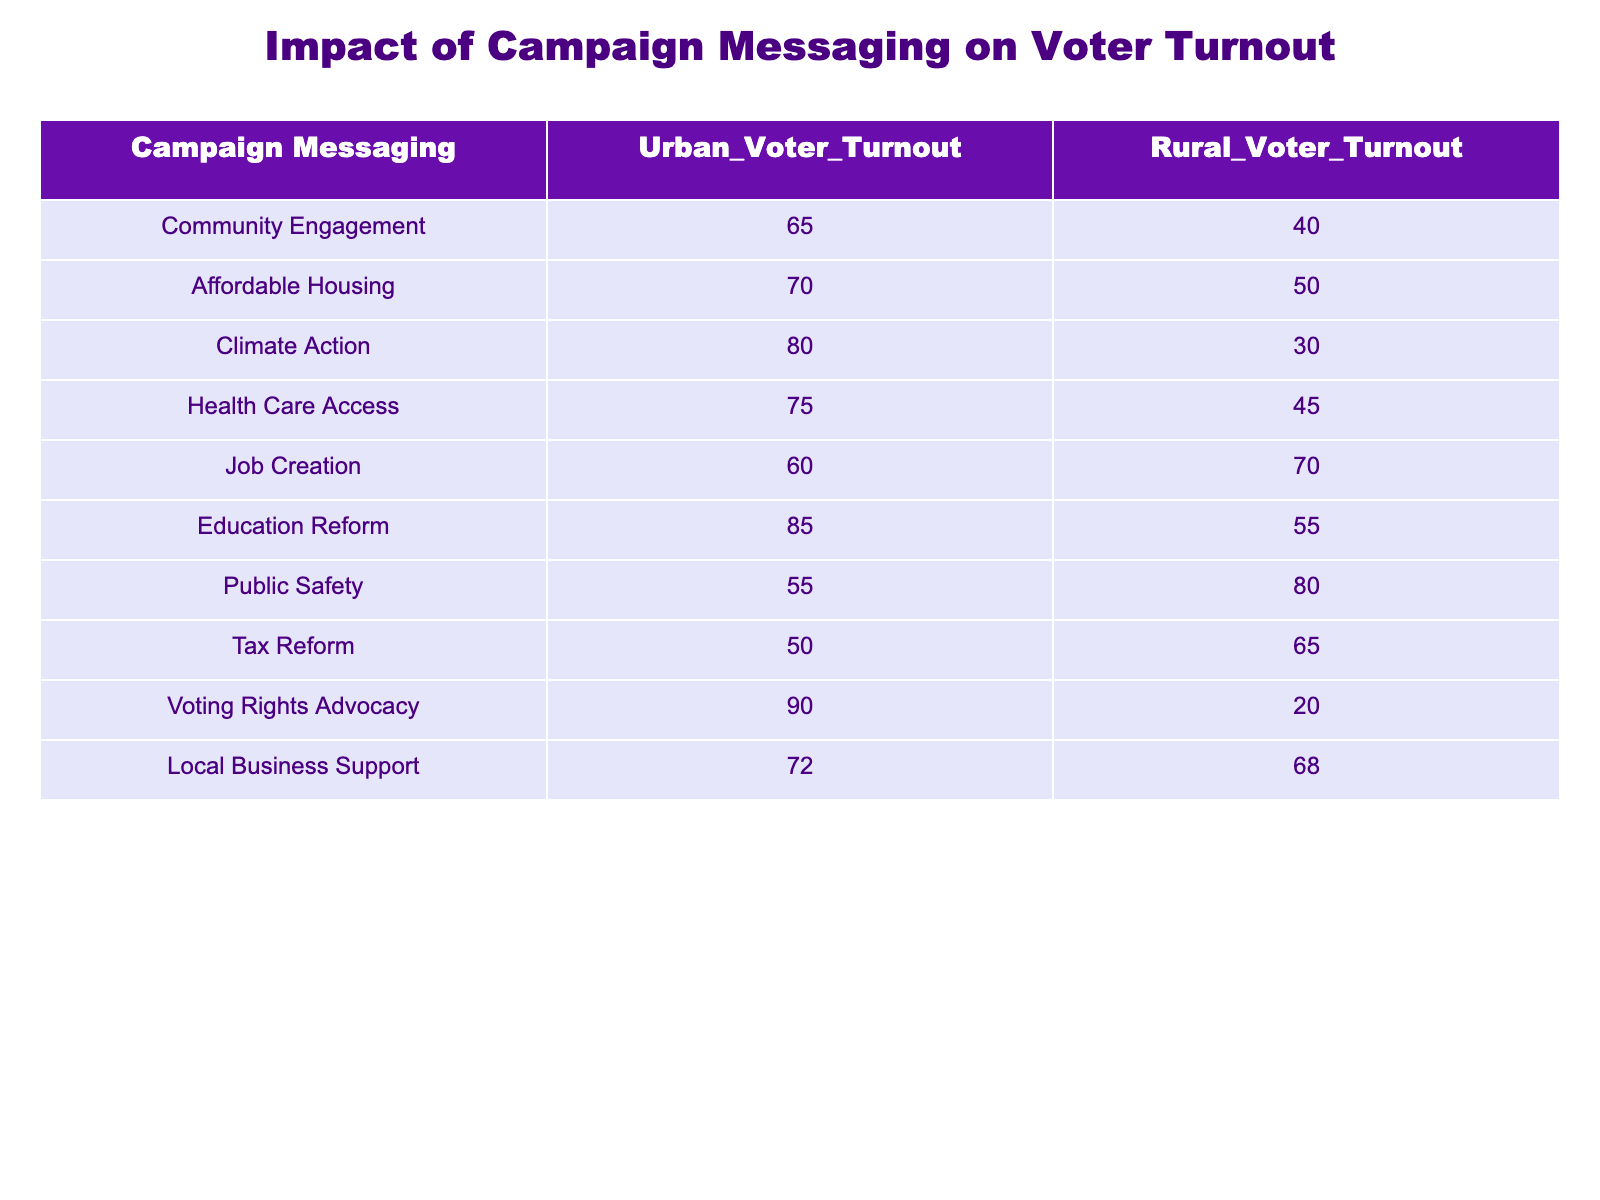What is the Urban Voter Turnout for "Climate Action"? The table lists the Urban Voter Turnout for each campaign messaging. For "Climate Action", the corresponding Urban Voter Turnout value is 80.
Answer: 80 What is the Rural Voter Turnout for "Job Creation"? Referring to the table, the Rural Voter Turnout for "Job Creation" is given as 70.
Answer: 70 Which campaign messaging has the lowest voter turnout in urban areas? By examining the Urban Voter Turnout values, "Tax Reform" shows the lowest turnout at 50 compared to other campaign messages.
Answer: Tax Reform Is the Urban Voter Turnout for "Local Business Support" higher than that for "Public Safety"? The Urban Voter Turnout for "Local Business Support" is 72 and for "Public Safety" it is 55. Since 72 is greater than 55, it is indeed higher.
Answer: Yes What is the average Urban Voter Turnout across all campaign messages? Adding the Urban Voter Turnout values (65 + 70 + 80 + 75 + 60 + 85 + 55 + 50 + 90 + 72 =  762) and dividing by the number of campaigns (10) yields an average of 76.2.
Answer: 76.2 Which messaging had the largest difference between Urban and Rural Voter Turnout? To find the largest difference, we calculate the absolute differences for each messaging: Climate Action: 50, Job Creation: 10, and so on. "Voting Rights Advocacy" has the largest difference of 70 (90-20).
Answer: Voting Rights Advocacy Is it true that "Health Care Access" has a higher Rural Voter Turnout than "Affordable Housing"? The Rural Voter Turnout for "Health Care Access" is 45, while for "Affordable Housing" it is 50. Since 45 is less than 50, the statement is false.
Answer: No What is the total Voter Turnout (Urban + Rural) for "Education Reform"? Adding the Urban (85) and Rural (55) Voter Turnout for "Education Reform" gives a total of 140 (85 + 55 = 140).
Answer: 140 How many campaign messages had an Urban Voter Turnout above 70? Reviewing the table, the campaign messages are "Affordable Housing", "Climate Action", "Health Care Access", "Education Reform", and "Local Business Support". There are 5 messages that fulfill this condition.
Answer: 5 What is the difference between the average Rural Voter Turnout and the average Urban Voter Turnout? The average Rural Voter Turnout can be calculated as (40 + 50 + 30 + 45 + 70 + 55 + 80 + 65 + 20 + 68 =  478) divided by 10, which gives 47.8. The average Urban Voter Turnout is already calculated as 76.2. Taking the difference, 76.2 - 47.8 results in 28.4.
Answer: 28.4 